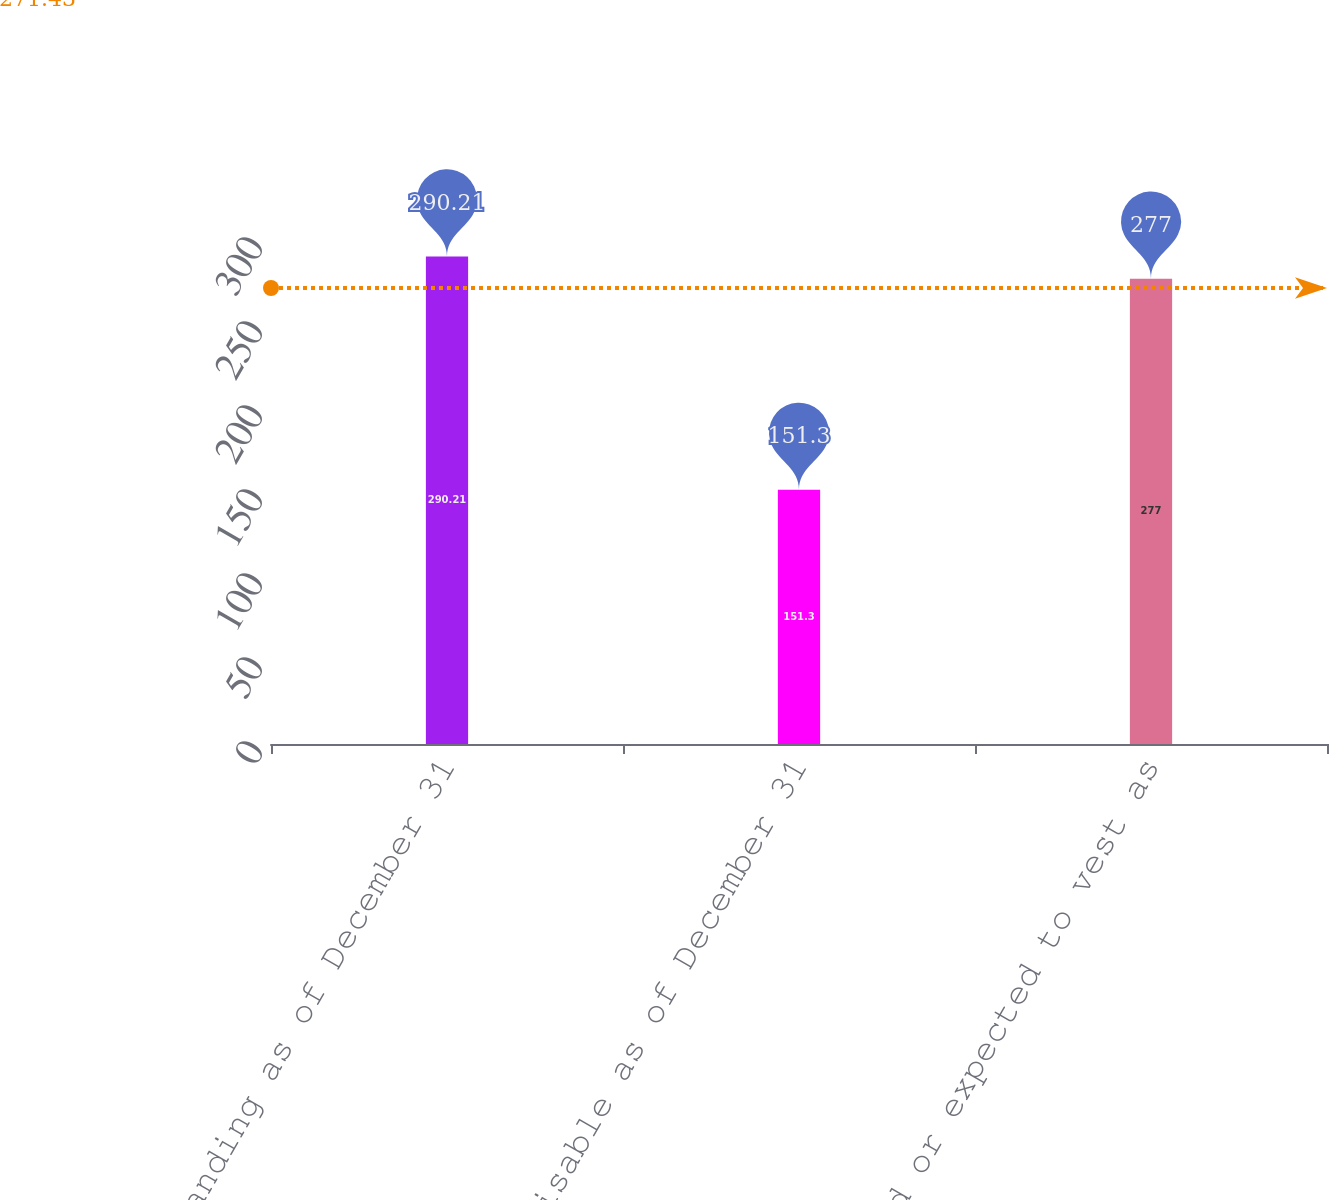Convert chart to OTSL. <chart><loc_0><loc_0><loc_500><loc_500><bar_chart><fcel>Outstanding as of December 31<fcel>Exercisable as of December 31<fcel>Vested or expected to vest as<nl><fcel>290.21<fcel>151.3<fcel>277<nl></chart> 